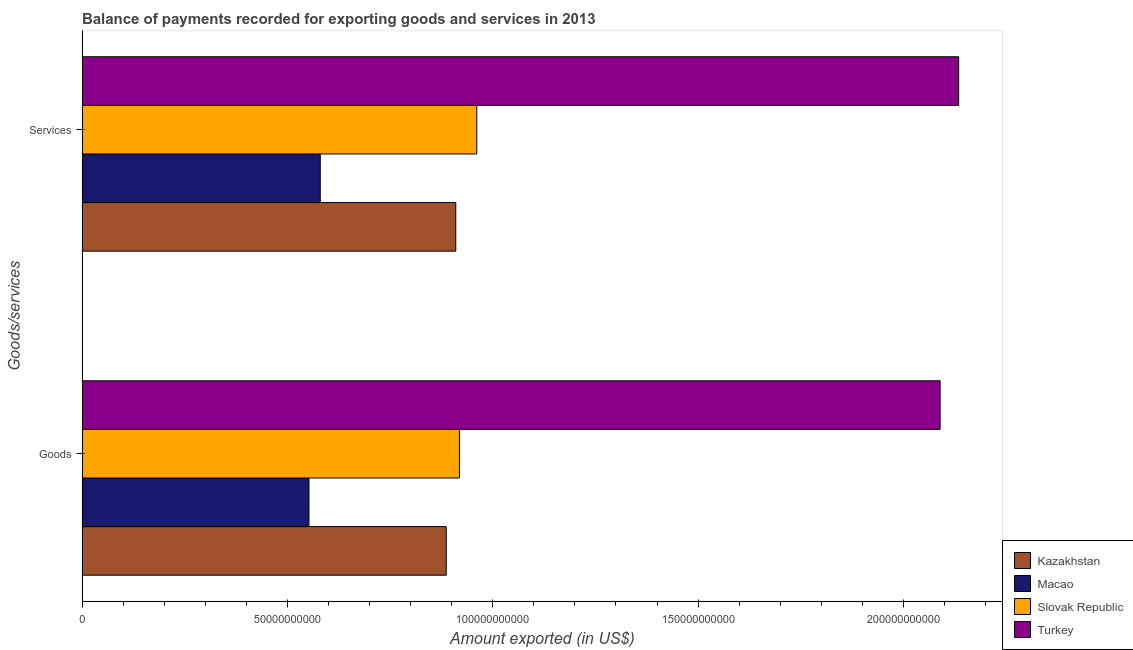How many groups of bars are there?
Your answer should be compact. 2. Are the number of bars per tick equal to the number of legend labels?
Provide a succinct answer. Yes. How many bars are there on the 2nd tick from the top?
Ensure brevity in your answer.  4. How many bars are there on the 1st tick from the bottom?
Offer a terse response. 4. What is the label of the 2nd group of bars from the top?
Offer a very short reply. Goods. What is the amount of services exported in Slovak Republic?
Your response must be concise. 9.61e+1. Across all countries, what is the maximum amount of services exported?
Your response must be concise. 2.13e+11. Across all countries, what is the minimum amount of services exported?
Ensure brevity in your answer.  5.80e+1. In which country was the amount of goods exported maximum?
Ensure brevity in your answer.  Turkey. In which country was the amount of services exported minimum?
Your response must be concise. Macao. What is the total amount of services exported in the graph?
Your answer should be very brief. 4.59e+11. What is the difference between the amount of services exported in Turkey and that in Macao?
Offer a very short reply. 1.55e+11. What is the difference between the amount of services exported in Kazakhstan and the amount of goods exported in Macao?
Ensure brevity in your answer.  3.57e+1. What is the average amount of services exported per country?
Give a very brief answer. 1.15e+11. What is the difference between the amount of services exported and amount of goods exported in Kazakhstan?
Provide a succinct answer. 2.32e+09. In how many countries, is the amount of goods exported greater than 10000000000 US$?
Offer a terse response. 4. What is the ratio of the amount of goods exported in Macao to that in Turkey?
Your answer should be compact. 0.26. Is the amount of goods exported in Kazakhstan less than that in Slovak Republic?
Provide a short and direct response. Yes. In how many countries, is the amount of goods exported greater than the average amount of goods exported taken over all countries?
Ensure brevity in your answer.  1. What does the 4th bar from the bottom in Services represents?
Your response must be concise. Turkey. How many bars are there?
Ensure brevity in your answer.  8. Are the values on the major ticks of X-axis written in scientific E-notation?
Your response must be concise. No. Does the graph contain any zero values?
Your answer should be very brief. No. Where does the legend appear in the graph?
Provide a short and direct response. Bottom right. How are the legend labels stacked?
Your response must be concise. Vertical. What is the title of the graph?
Ensure brevity in your answer.  Balance of payments recorded for exporting goods and services in 2013. Does "Botswana" appear as one of the legend labels in the graph?
Provide a short and direct response. No. What is the label or title of the X-axis?
Provide a succinct answer. Amount exported (in US$). What is the label or title of the Y-axis?
Give a very brief answer. Goods/services. What is the Amount exported (in US$) in Kazakhstan in Goods?
Ensure brevity in your answer.  8.87e+1. What is the Amount exported (in US$) of Macao in Goods?
Your response must be concise. 5.53e+1. What is the Amount exported (in US$) in Slovak Republic in Goods?
Offer a terse response. 9.19e+1. What is the Amount exported (in US$) in Turkey in Goods?
Provide a succinct answer. 2.09e+11. What is the Amount exported (in US$) of Kazakhstan in Services?
Ensure brevity in your answer.  9.10e+1. What is the Amount exported (in US$) of Macao in Services?
Offer a very short reply. 5.80e+1. What is the Amount exported (in US$) in Slovak Republic in Services?
Make the answer very short. 9.61e+1. What is the Amount exported (in US$) of Turkey in Services?
Provide a short and direct response. 2.13e+11. Across all Goods/services, what is the maximum Amount exported (in US$) in Kazakhstan?
Make the answer very short. 9.10e+1. Across all Goods/services, what is the maximum Amount exported (in US$) in Macao?
Offer a very short reply. 5.80e+1. Across all Goods/services, what is the maximum Amount exported (in US$) of Slovak Republic?
Provide a succinct answer. 9.61e+1. Across all Goods/services, what is the maximum Amount exported (in US$) of Turkey?
Your response must be concise. 2.13e+11. Across all Goods/services, what is the minimum Amount exported (in US$) in Kazakhstan?
Provide a short and direct response. 8.87e+1. Across all Goods/services, what is the minimum Amount exported (in US$) in Macao?
Your answer should be very brief. 5.53e+1. Across all Goods/services, what is the minimum Amount exported (in US$) of Slovak Republic?
Your answer should be compact. 9.19e+1. Across all Goods/services, what is the minimum Amount exported (in US$) of Turkey?
Ensure brevity in your answer.  2.09e+11. What is the total Amount exported (in US$) in Kazakhstan in the graph?
Your answer should be compact. 1.80e+11. What is the total Amount exported (in US$) of Macao in the graph?
Make the answer very short. 1.13e+11. What is the total Amount exported (in US$) of Slovak Republic in the graph?
Make the answer very short. 1.88e+11. What is the total Amount exported (in US$) in Turkey in the graph?
Your answer should be compact. 4.22e+11. What is the difference between the Amount exported (in US$) of Kazakhstan in Goods and that in Services?
Offer a terse response. -2.32e+09. What is the difference between the Amount exported (in US$) of Macao in Goods and that in Services?
Provide a succinct answer. -2.75e+09. What is the difference between the Amount exported (in US$) of Slovak Republic in Goods and that in Services?
Keep it short and to the point. -4.21e+09. What is the difference between the Amount exported (in US$) of Turkey in Goods and that in Services?
Your answer should be compact. -4.52e+09. What is the difference between the Amount exported (in US$) of Kazakhstan in Goods and the Amount exported (in US$) of Macao in Services?
Make the answer very short. 3.07e+1. What is the difference between the Amount exported (in US$) of Kazakhstan in Goods and the Amount exported (in US$) of Slovak Republic in Services?
Provide a short and direct response. -7.43e+09. What is the difference between the Amount exported (in US$) in Kazakhstan in Goods and the Amount exported (in US$) in Turkey in Services?
Your response must be concise. -1.25e+11. What is the difference between the Amount exported (in US$) of Macao in Goods and the Amount exported (in US$) of Slovak Republic in Services?
Give a very brief answer. -4.09e+1. What is the difference between the Amount exported (in US$) of Macao in Goods and the Amount exported (in US$) of Turkey in Services?
Provide a succinct answer. -1.58e+11. What is the difference between the Amount exported (in US$) in Slovak Republic in Goods and the Amount exported (in US$) in Turkey in Services?
Ensure brevity in your answer.  -1.22e+11. What is the average Amount exported (in US$) of Kazakhstan per Goods/services?
Keep it short and to the point. 8.98e+1. What is the average Amount exported (in US$) in Macao per Goods/services?
Provide a short and direct response. 5.66e+1. What is the average Amount exported (in US$) of Slovak Republic per Goods/services?
Your response must be concise. 9.40e+1. What is the average Amount exported (in US$) of Turkey per Goods/services?
Your response must be concise. 2.11e+11. What is the difference between the Amount exported (in US$) in Kazakhstan and Amount exported (in US$) in Macao in Goods?
Provide a short and direct response. 3.34e+1. What is the difference between the Amount exported (in US$) in Kazakhstan and Amount exported (in US$) in Slovak Republic in Goods?
Provide a short and direct response. -3.22e+09. What is the difference between the Amount exported (in US$) in Kazakhstan and Amount exported (in US$) in Turkey in Goods?
Ensure brevity in your answer.  -1.20e+11. What is the difference between the Amount exported (in US$) of Macao and Amount exported (in US$) of Slovak Republic in Goods?
Your response must be concise. -3.66e+1. What is the difference between the Amount exported (in US$) in Macao and Amount exported (in US$) in Turkey in Goods?
Keep it short and to the point. -1.54e+11. What is the difference between the Amount exported (in US$) of Slovak Republic and Amount exported (in US$) of Turkey in Goods?
Your answer should be compact. -1.17e+11. What is the difference between the Amount exported (in US$) in Kazakhstan and Amount exported (in US$) in Macao in Services?
Ensure brevity in your answer.  3.30e+1. What is the difference between the Amount exported (in US$) of Kazakhstan and Amount exported (in US$) of Slovak Republic in Services?
Your answer should be very brief. -5.11e+09. What is the difference between the Amount exported (in US$) in Kazakhstan and Amount exported (in US$) in Turkey in Services?
Your answer should be compact. -1.22e+11. What is the difference between the Amount exported (in US$) in Macao and Amount exported (in US$) in Slovak Republic in Services?
Provide a short and direct response. -3.81e+1. What is the difference between the Amount exported (in US$) in Macao and Amount exported (in US$) in Turkey in Services?
Your response must be concise. -1.55e+11. What is the difference between the Amount exported (in US$) of Slovak Republic and Amount exported (in US$) of Turkey in Services?
Keep it short and to the point. -1.17e+11. What is the ratio of the Amount exported (in US$) in Kazakhstan in Goods to that in Services?
Offer a very short reply. 0.97. What is the ratio of the Amount exported (in US$) of Macao in Goods to that in Services?
Provide a succinct answer. 0.95. What is the ratio of the Amount exported (in US$) in Slovak Republic in Goods to that in Services?
Keep it short and to the point. 0.96. What is the ratio of the Amount exported (in US$) of Turkey in Goods to that in Services?
Offer a terse response. 0.98. What is the difference between the highest and the second highest Amount exported (in US$) in Kazakhstan?
Keep it short and to the point. 2.32e+09. What is the difference between the highest and the second highest Amount exported (in US$) in Macao?
Provide a short and direct response. 2.75e+09. What is the difference between the highest and the second highest Amount exported (in US$) of Slovak Republic?
Your answer should be compact. 4.21e+09. What is the difference between the highest and the second highest Amount exported (in US$) in Turkey?
Your answer should be compact. 4.52e+09. What is the difference between the highest and the lowest Amount exported (in US$) in Kazakhstan?
Offer a very short reply. 2.32e+09. What is the difference between the highest and the lowest Amount exported (in US$) of Macao?
Offer a terse response. 2.75e+09. What is the difference between the highest and the lowest Amount exported (in US$) of Slovak Republic?
Offer a terse response. 4.21e+09. What is the difference between the highest and the lowest Amount exported (in US$) in Turkey?
Offer a terse response. 4.52e+09. 